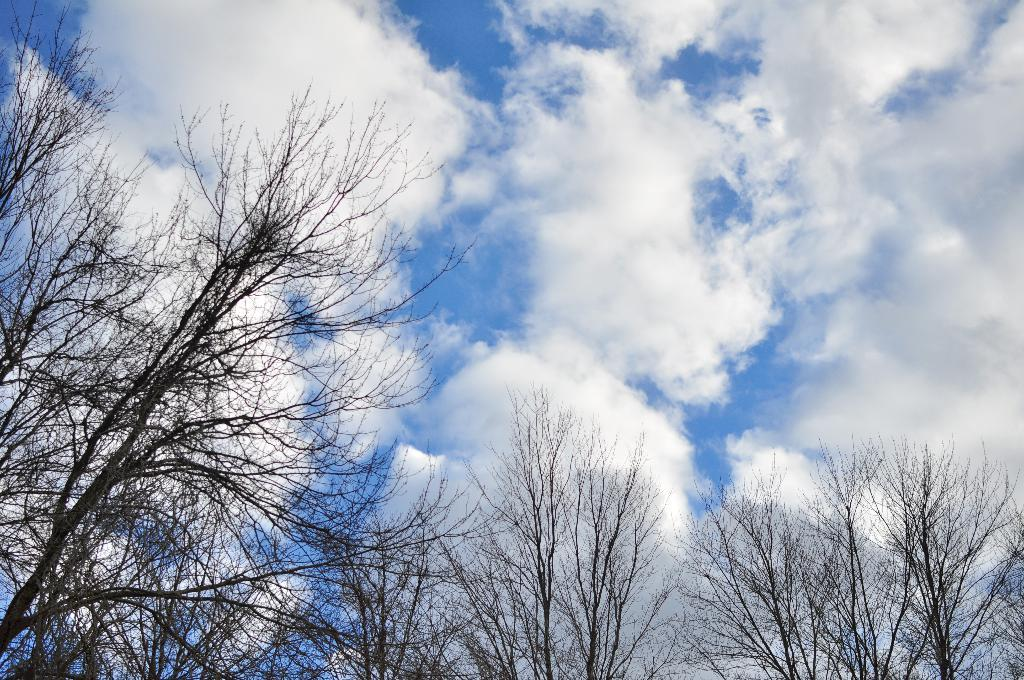What type of vegetation is at the bottom of the image? There are trees at the bottom of the image. What can be seen in the background of the image? There are clouds in the background of the image. What color is the sky in the image? The sky is blue in color. How many men are helping to clean the dust in the image? There are no men or dust present in the image. What type of help can be seen being provided in the image? There is no help being provided in the image; it only features trees, clouds, and a blue sky. 